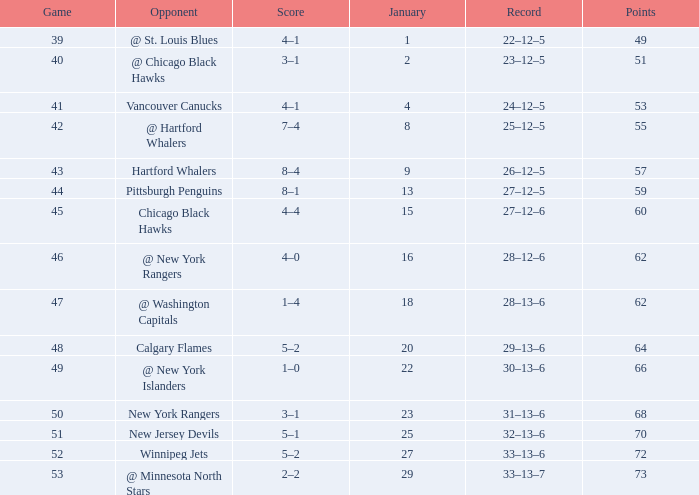How many games have a Score of 1–0, and Points smaller than 66? 0.0. 